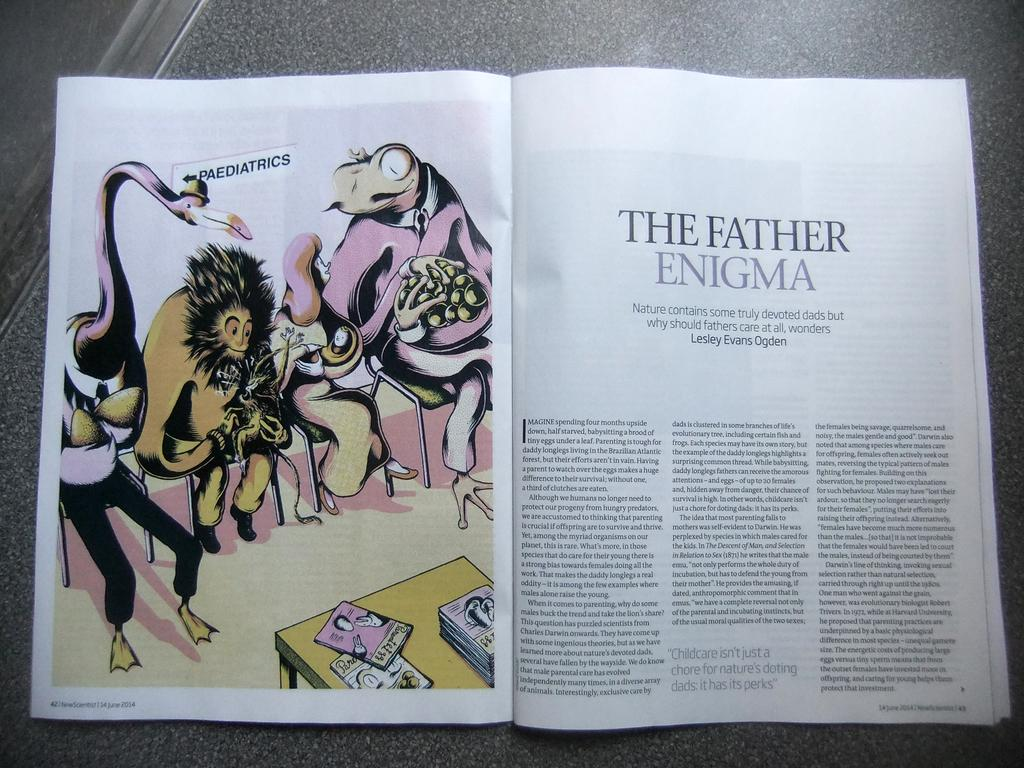<image>
Summarize the visual content of the image. A magazine article is titled, The Father Enigma. 